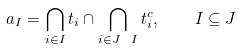<formula> <loc_0><loc_0><loc_500><loc_500>a _ { I } = \bigcap _ { i \in I } t _ { i } \cap \bigcap _ { i \in J \ I } t _ { i } ^ { c } , \quad I \subseteq J</formula> 